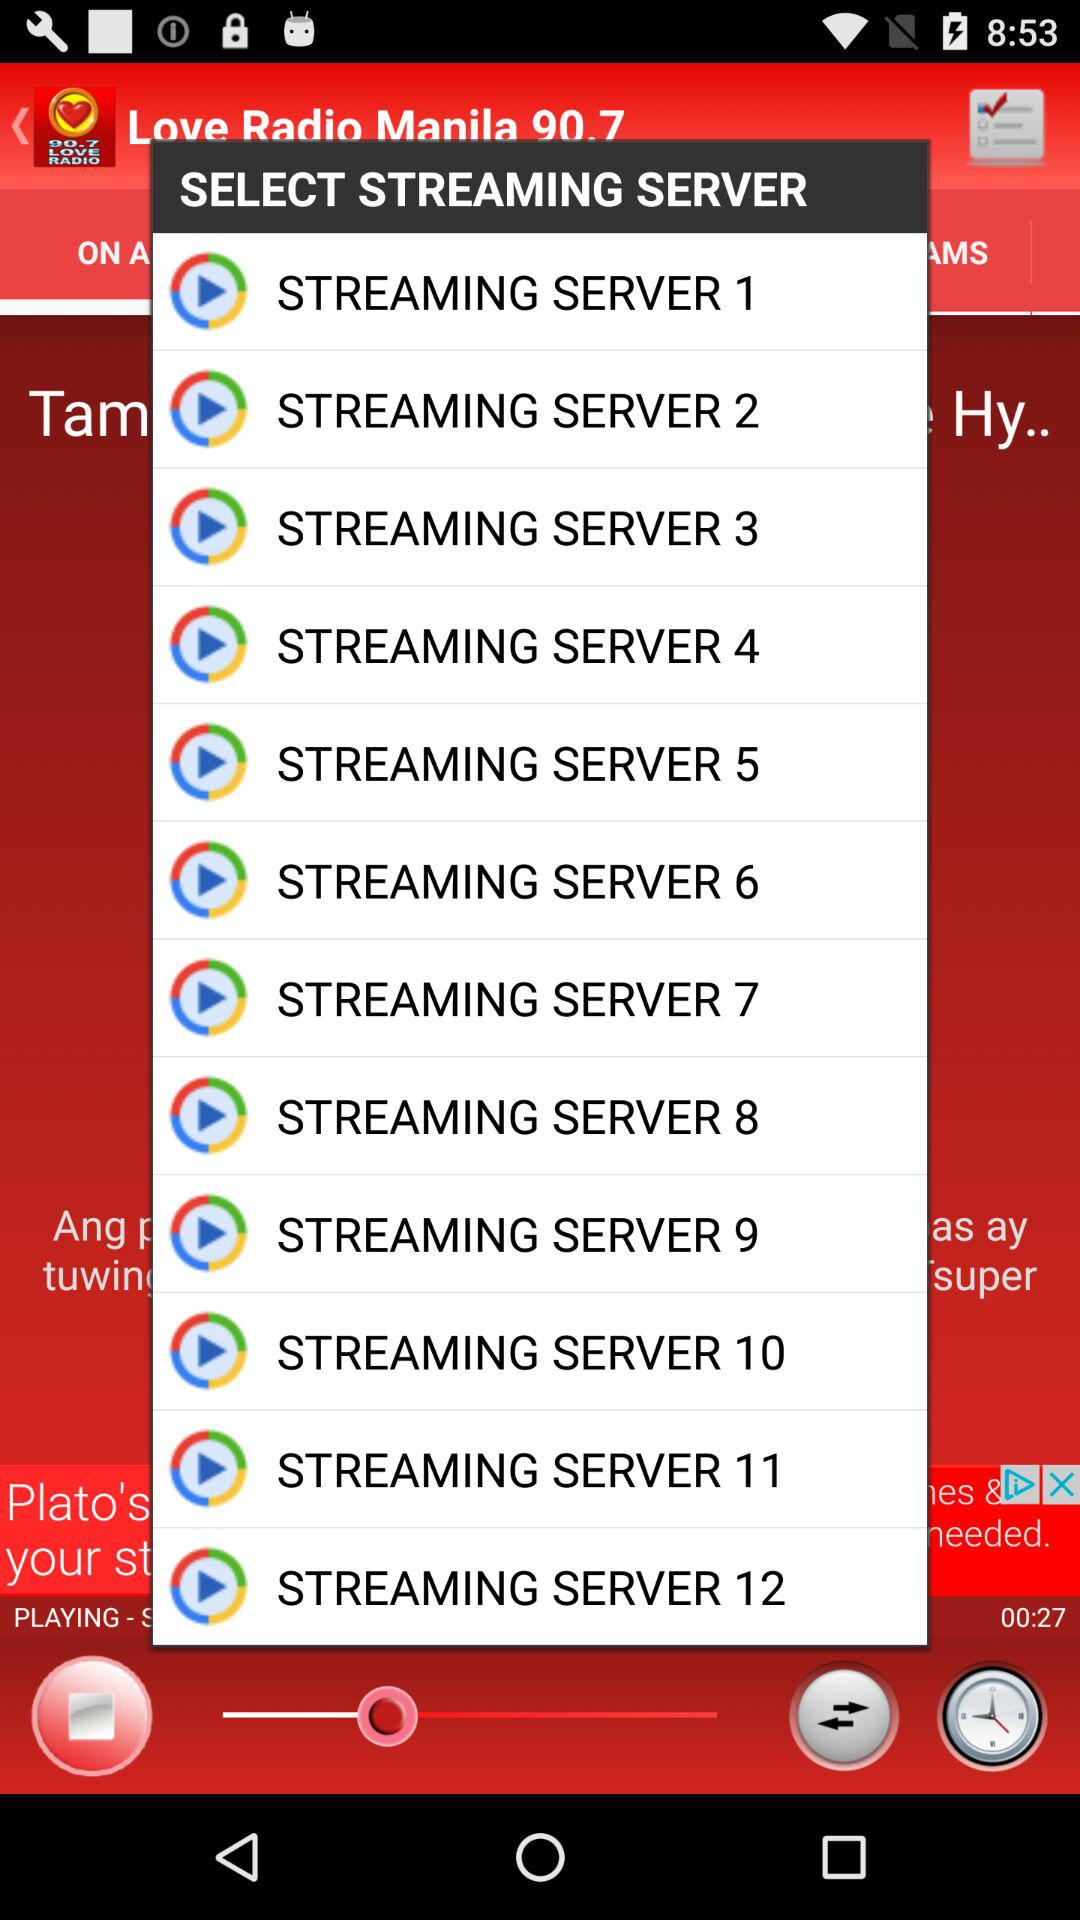What is the name of the radio channel? The name of the radio channel is "Love Radio Manila 90.7". 